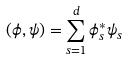<formula> <loc_0><loc_0><loc_500><loc_500>( \phi , \psi ) = \sum _ { s = 1 } ^ { d } \phi _ { s } ^ { * } \psi _ { s }</formula> 